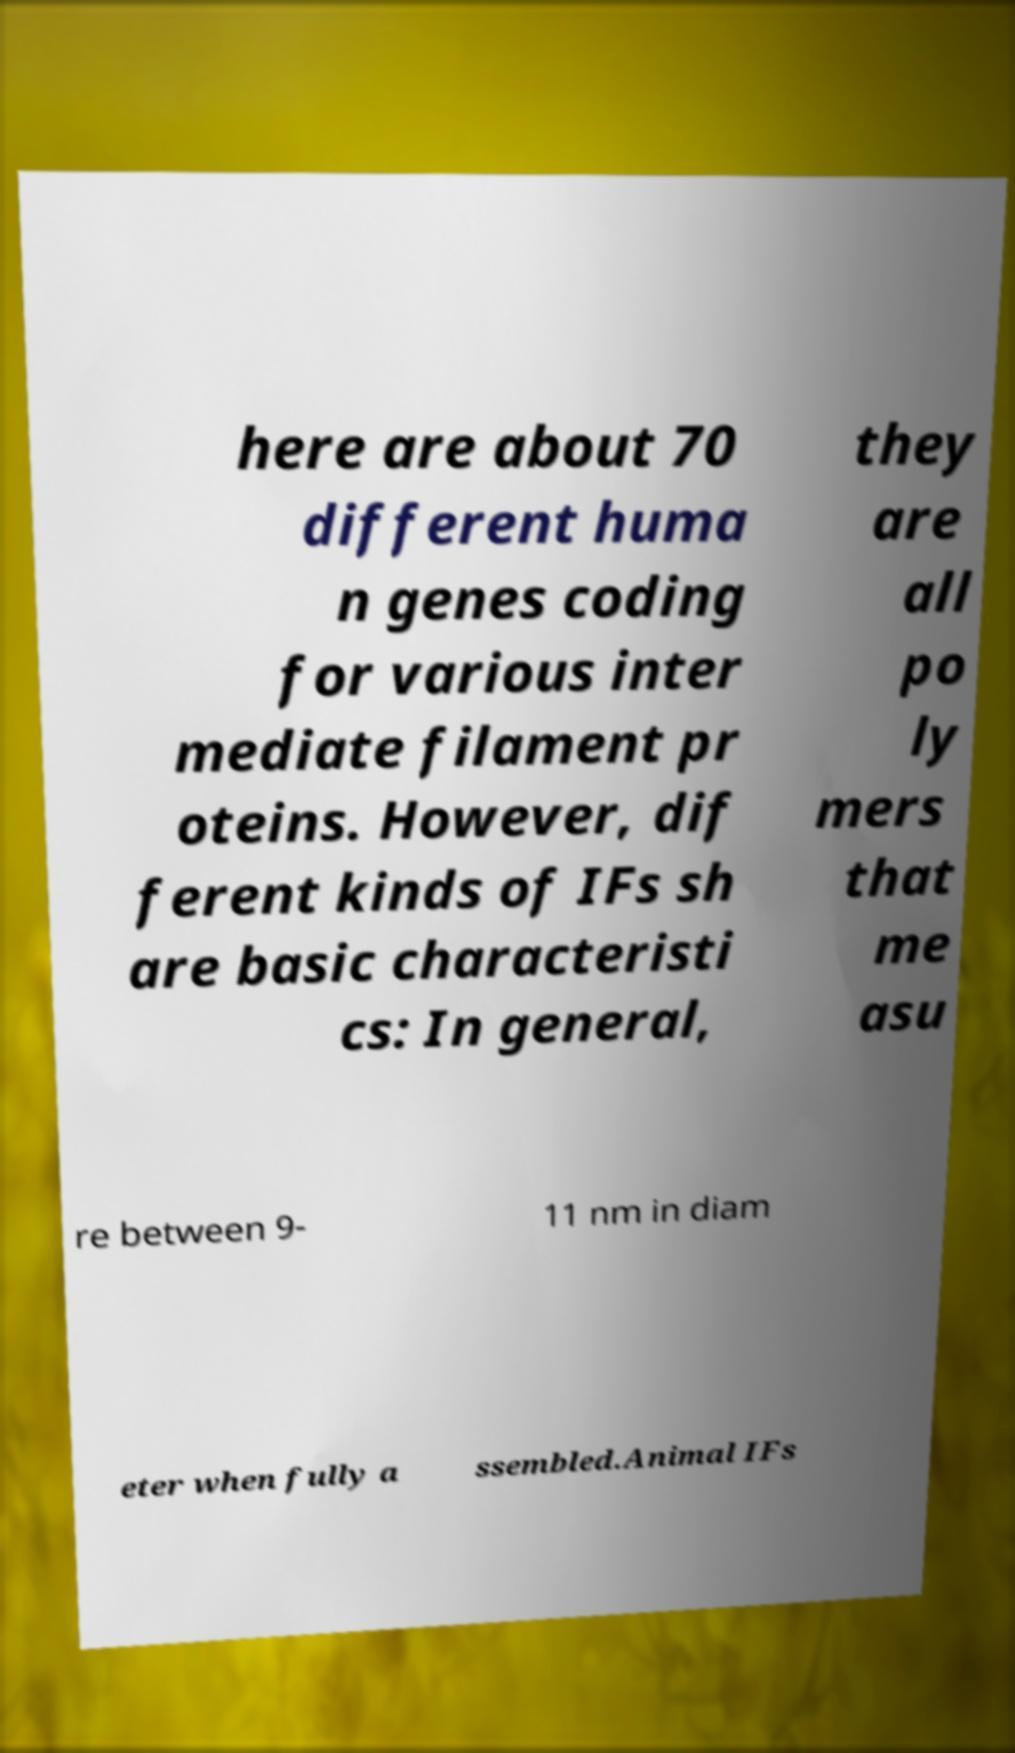Could you assist in decoding the text presented in this image and type it out clearly? here are about 70 different huma n genes coding for various inter mediate filament pr oteins. However, dif ferent kinds of IFs sh are basic characteristi cs: In general, they are all po ly mers that me asu re between 9- 11 nm in diam eter when fully a ssembled.Animal IFs 